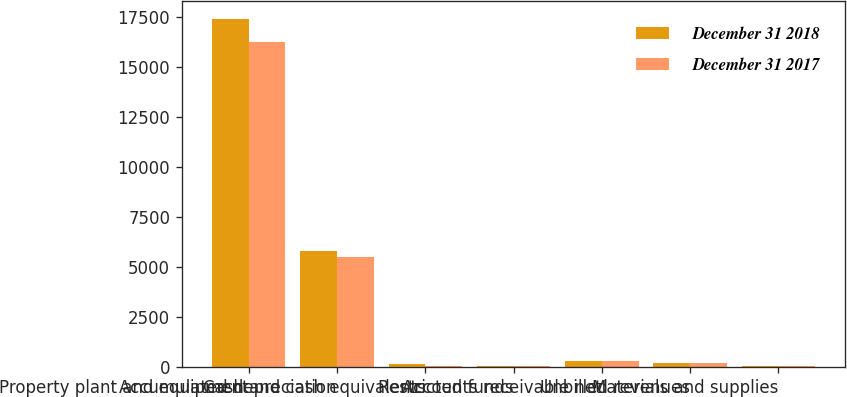Convert chart to OTSL. <chart><loc_0><loc_0><loc_500><loc_500><stacked_bar_chart><ecel><fcel>Property plant and equipment<fcel>Accumulated depreciation<fcel>Cash and cash equivalents<fcel>Restricted funds<fcel>Accounts receivable net<fcel>Unbilled revenues<fcel>Materials and supplies<nl><fcel>December 31 2018<fcel>17409<fcel>5795<fcel>130<fcel>28<fcel>301<fcel>186<fcel>41<nl><fcel>December 31 2017<fcel>16246<fcel>5470<fcel>55<fcel>27<fcel>272<fcel>212<fcel>41<nl></chart> 